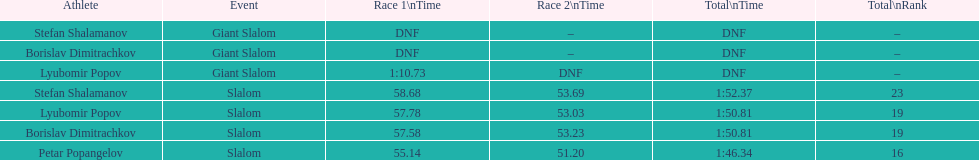Which athlete had a race time above 1:00? Lyubomir Popov. 